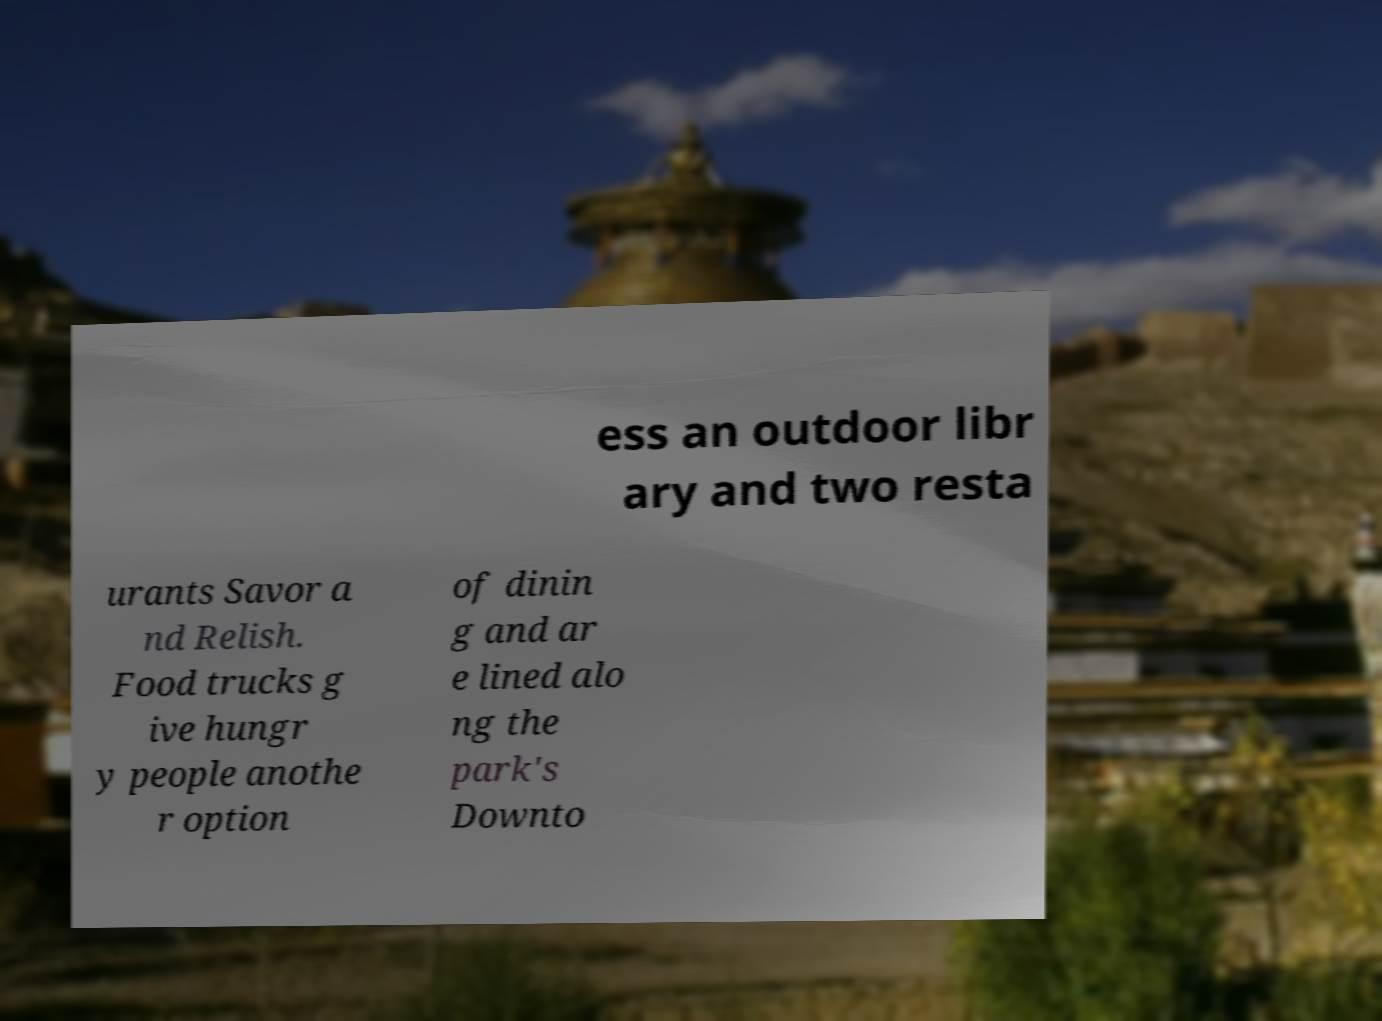What messages or text are displayed in this image? I need them in a readable, typed format. ess an outdoor libr ary and two resta urants Savor a nd Relish. Food trucks g ive hungr y people anothe r option of dinin g and ar e lined alo ng the park's Downto 